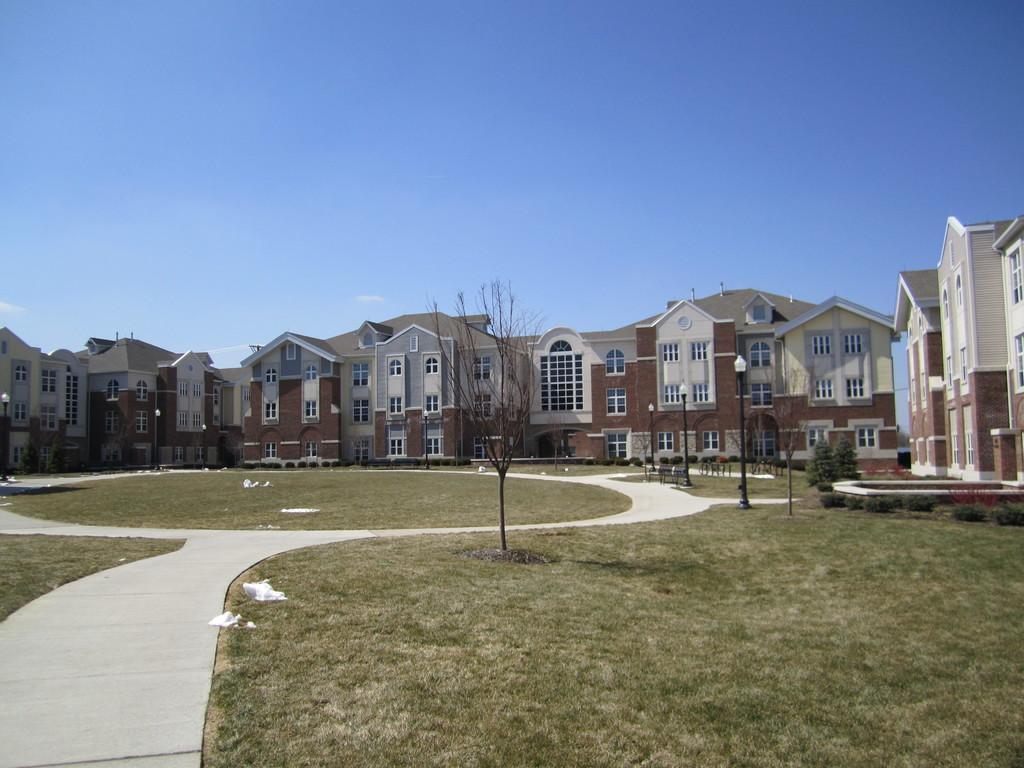Please provide a concise description of this image. In this image, we can see buildings, trees, poles and at the bottom, there is ground. At the top, there is sky. 